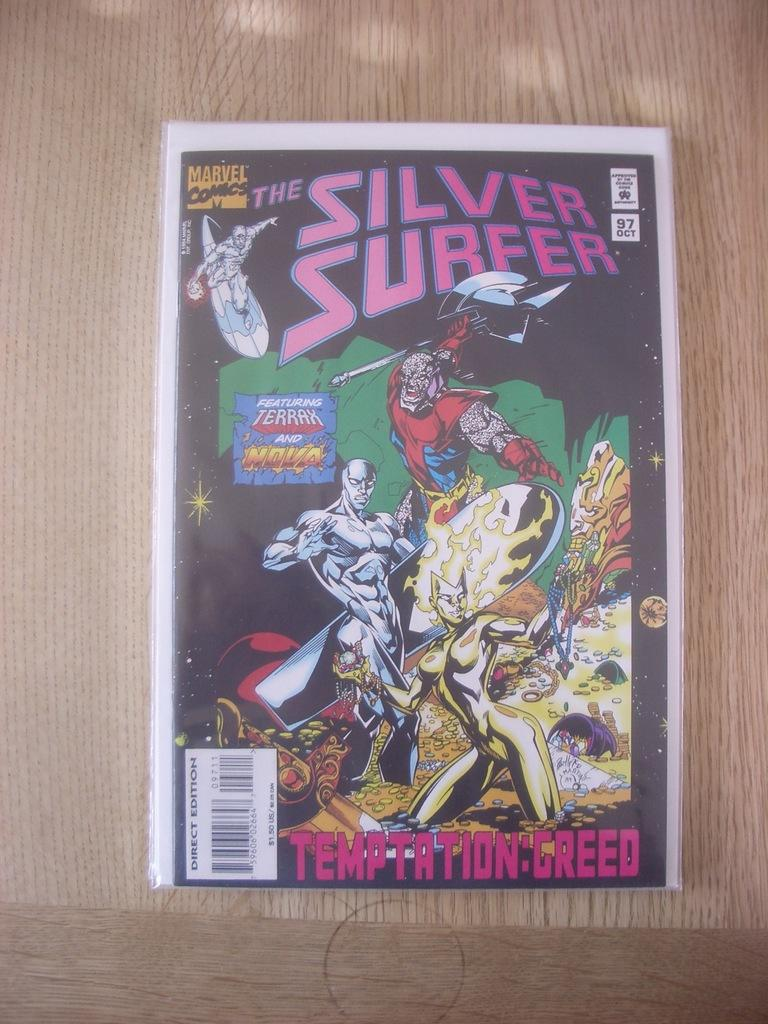<image>
Share a concise interpretation of the image provided. the cover of a magazine that says 'the silver surfer' on it 